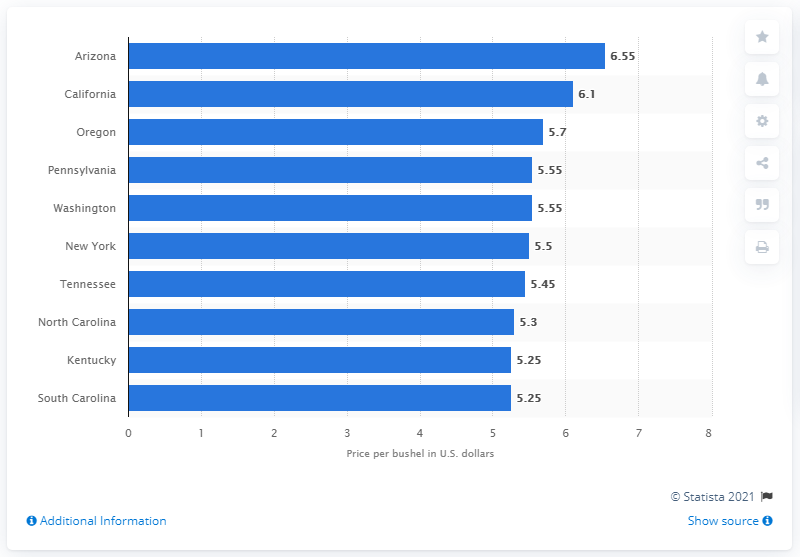What insights can be gathered from the wheat prices across these states? This data reveals regional variations in wheat prices, which could be due to factors like climate conditions, supply and demand, and transportation costs. For example, Arizona leading with the highest price may suggest a lower supply or higher production costs compared to other states. 